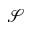Convert formula to latex. <formula><loc_0><loc_0><loc_500><loc_500>\ m a t h s c r { S }</formula> 